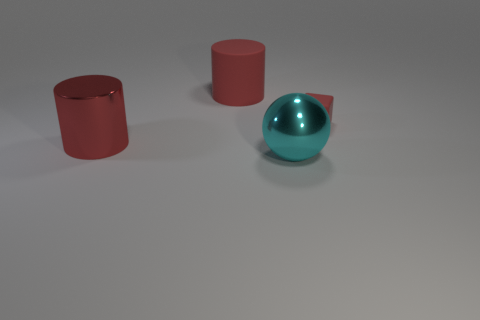Add 1 big metal objects. How many objects exist? 5 Subtract all balls. How many objects are left? 3 Add 2 red cylinders. How many red cylinders are left? 4 Add 2 tiny green shiny objects. How many tiny green shiny objects exist? 2 Subtract 0 red balls. How many objects are left? 4 Subtract all large red things. Subtract all small red rubber things. How many objects are left? 1 